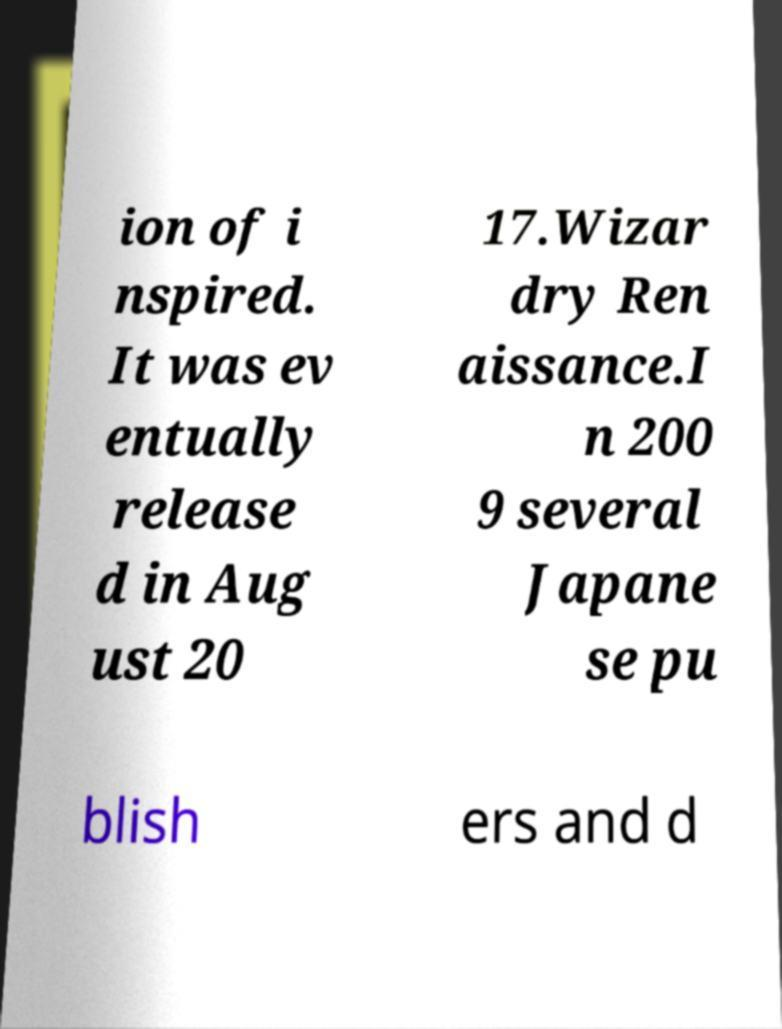For documentation purposes, I need the text within this image transcribed. Could you provide that? ion of i nspired. It was ev entually release d in Aug ust 20 17.Wizar dry Ren aissance.I n 200 9 several Japane se pu blish ers and d 